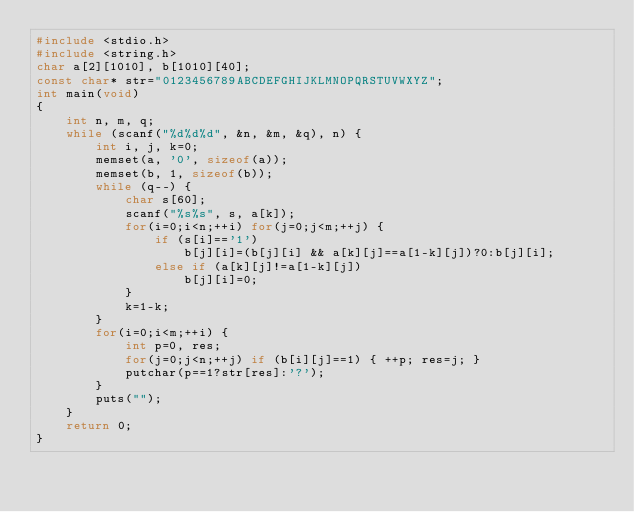<code> <loc_0><loc_0><loc_500><loc_500><_C_>#include <stdio.h>
#include <string.h>
char a[2][1010], b[1010][40];
const char* str="0123456789ABCDEFGHIJKLMNOPQRSTUVWXYZ";
int main(void)
{
    int n, m, q;
    while (scanf("%d%d%d", &n, &m, &q), n) {
        int i, j, k=0;
        memset(a, '0', sizeof(a));
        memset(b, 1, sizeof(b));
        while (q--) {
            char s[60];
            scanf("%s%s", s, a[k]);
            for(i=0;i<n;++i) for(j=0;j<m;++j) {
                if (s[i]=='1')
                    b[j][i]=(b[j][i] && a[k][j]==a[1-k][j])?0:b[j][i];
                else if (a[k][j]!=a[1-k][j])
                    b[j][i]=0;
            }
            k=1-k;
        }
        for(i=0;i<m;++i) {
            int p=0, res;
            for(j=0;j<n;++j) if (b[i][j]==1) { ++p; res=j; }
            putchar(p==1?str[res]:'?');
        }
        puts("");
    }
    return 0;
}</code> 